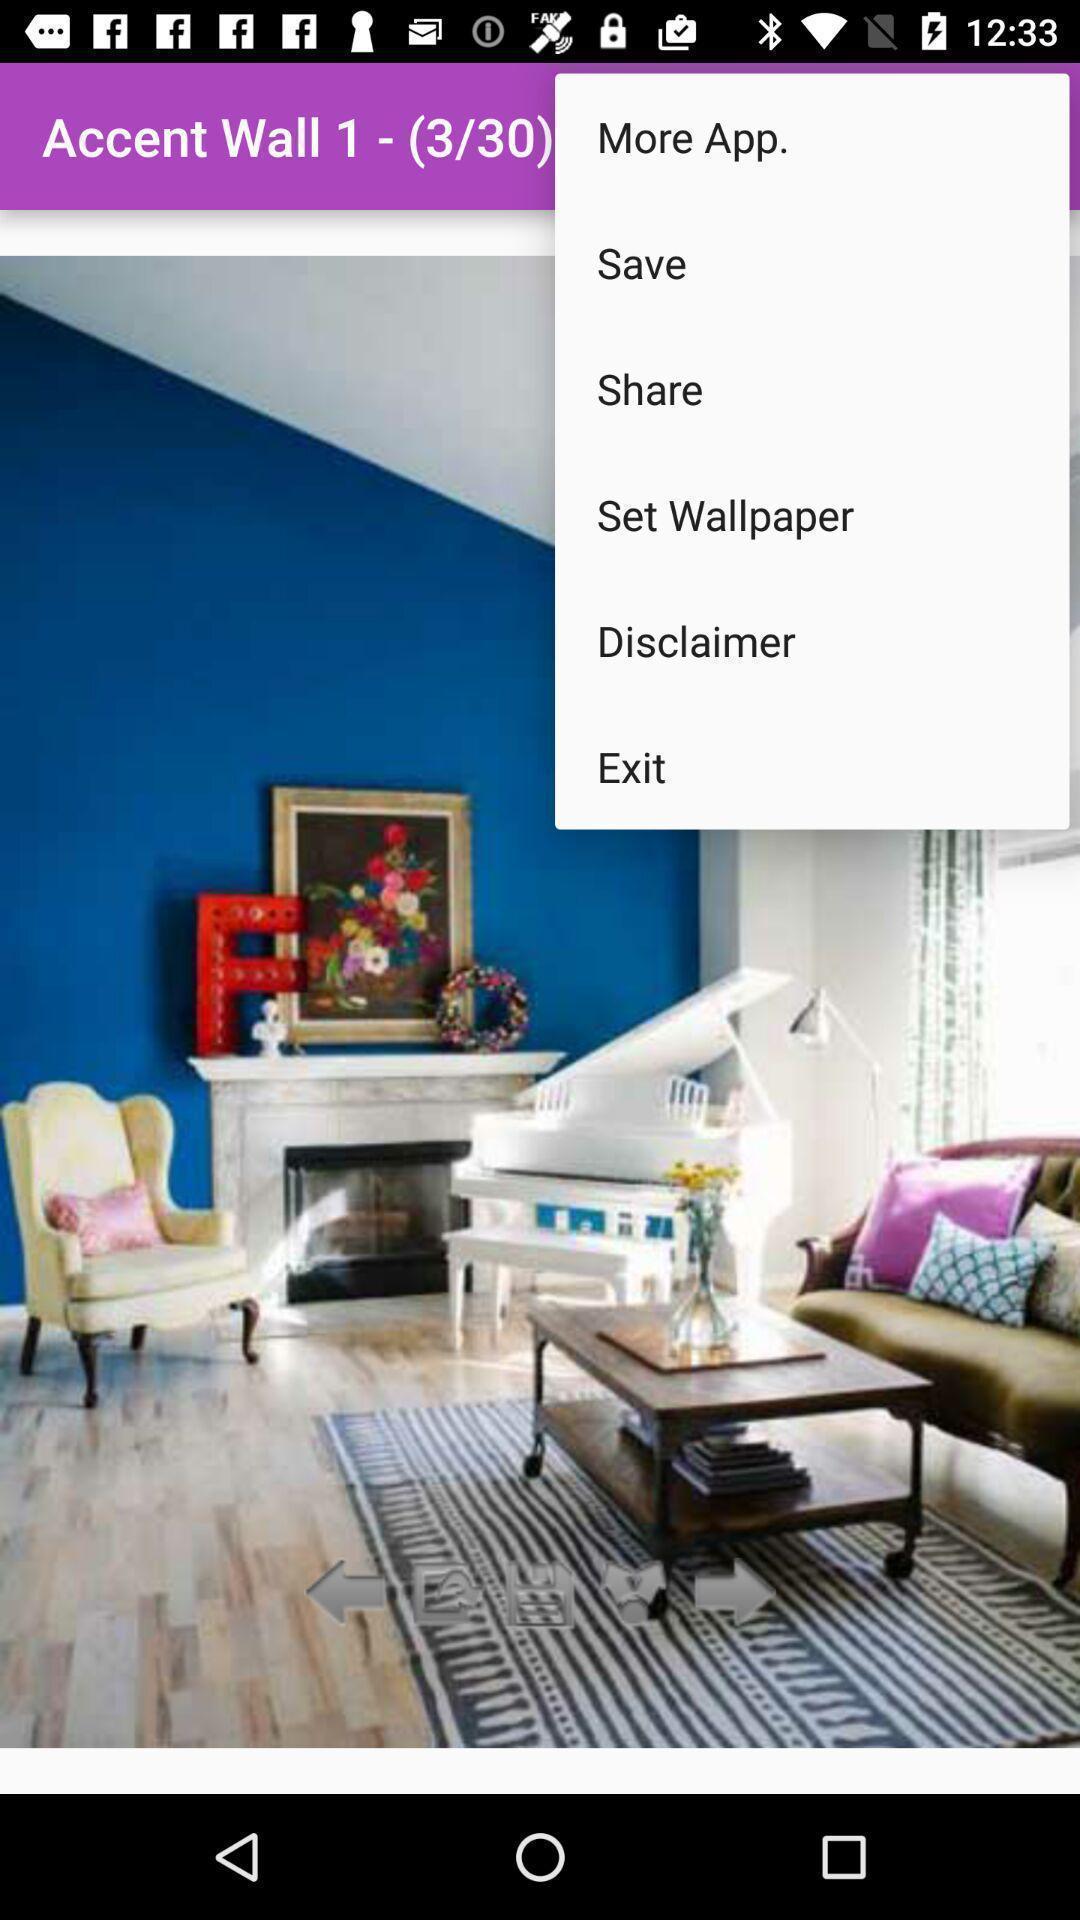Summarize the information in this screenshot. Screen showing settings on a wallpaper. 